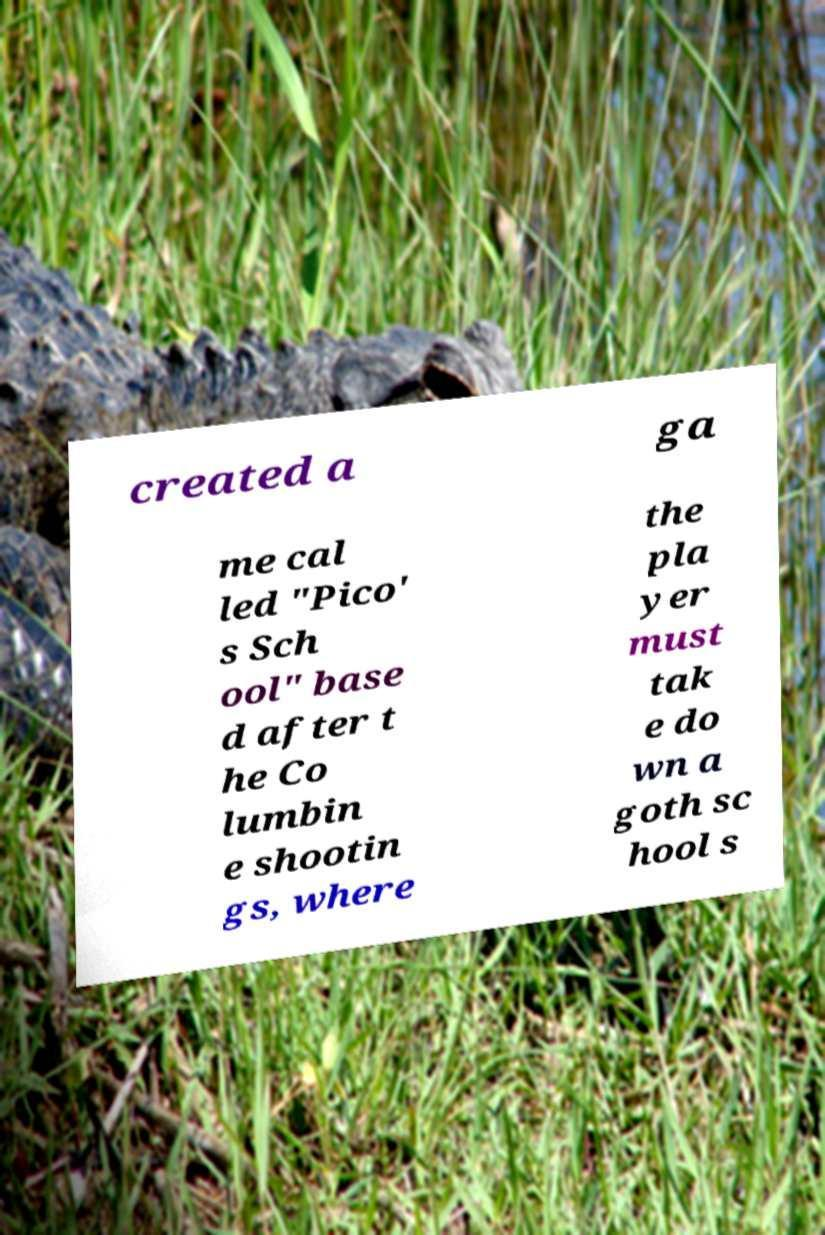Can you accurately transcribe the text from the provided image for me? created a ga me cal led "Pico' s Sch ool" base d after t he Co lumbin e shootin gs, where the pla yer must tak e do wn a goth sc hool s 